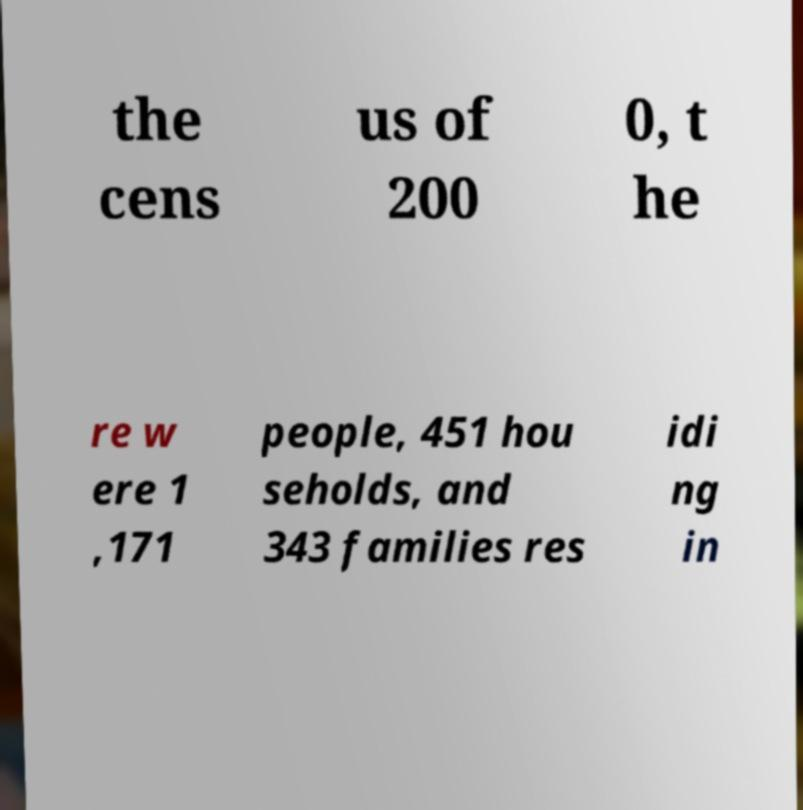What messages or text are displayed in this image? I need them in a readable, typed format. the cens us of 200 0, t he re w ere 1 ,171 people, 451 hou seholds, and 343 families res idi ng in 